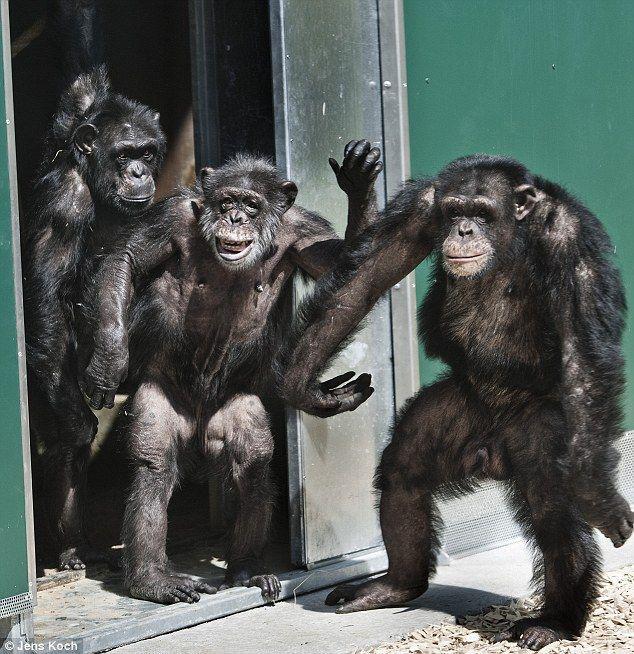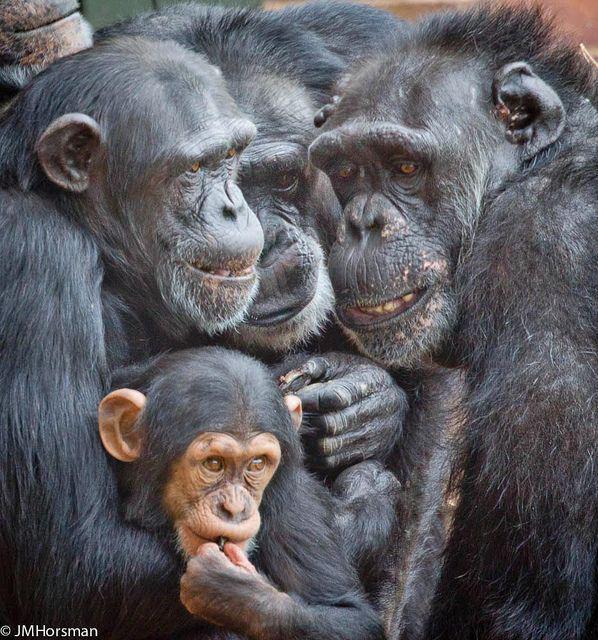The first image is the image on the left, the second image is the image on the right. Analyze the images presented: Is the assertion "Each image includes a baby ape in front of an adult ape." valid? Answer yes or no. No. The first image is the image on the left, the second image is the image on the right. Examine the images to the left and right. Is the description "There are fewer than five chimpanzees in total." accurate? Answer yes or no. No. 